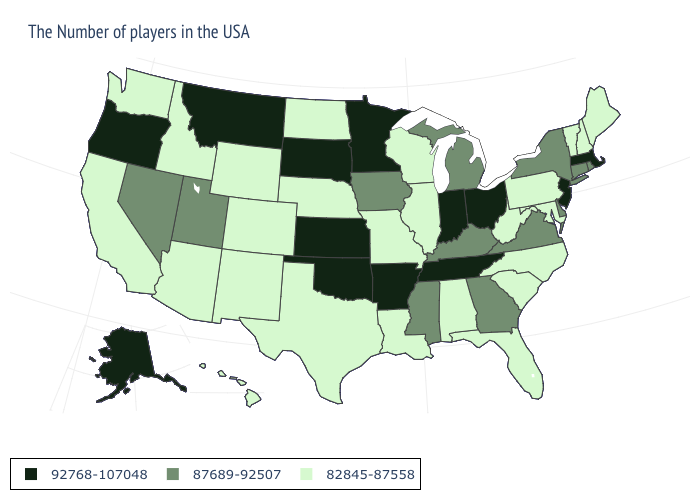What is the value of New Mexico?
Concise answer only. 82845-87558. Which states have the lowest value in the MidWest?
Keep it brief. Wisconsin, Illinois, Missouri, Nebraska, North Dakota. What is the highest value in the West ?
Quick response, please. 92768-107048. Which states have the highest value in the USA?
Write a very short answer. Massachusetts, New Jersey, Ohio, Indiana, Tennessee, Arkansas, Minnesota, Kansas, Oklahoma, South Dakota, Montana, Oregon, Alaska. Name the states that have a value in the range 87689-92507?
Give a very brief answer. Rhode Island, Connecticut, New York, Delaware, Virginia, Georgia, Michigan, Kentucky, Mississippi, Iowa, Utah, Nevada. Does Tennessee have the highest value in the USA?
Concise answer only. Yes. Which states have the lowest value in the West?
Concise answer only. Wyoming, Colorado, New Mexico, Arizona, Idaho, California, Washington, Hawaii. Does the map have missing data?
Concise answer only. No. Does the map have missing data?
Answer briefly. No. Name the states that have a value in the range 92768-107048?
Write a very short answer. Massachusetts, New Jersey, Ohio, Indiana, Tennessee, Arkansas, Minnesota, Kansas, Oklahoma, South Dakota, Montana, Oregon, Alaska. Name the states that have a value in the range 92768-107048?
Short answer required. Massachusetts, New Jersey, Ohio, Indiana, Tennessee, Arkansas, Minnesota, Kansas, Oklahoma, South Dakota, Montana, Oregon, Alaska. Name the states that have a value in the range 87689-92507?
Be succinct. Rhode Island, Connecticut, New York, Delaware, Virginia, Georgia, Michigan, Kentucky, Mississippi, Iowa, Utah, Nevada. Does Connecticut have the lowest value in the Northeast?
Concise answer only. No. Which states hav the highest value in the MidWest?
Answer briefly. Ohio, Indiana, Minnesota, Kansas, South Dakota. 